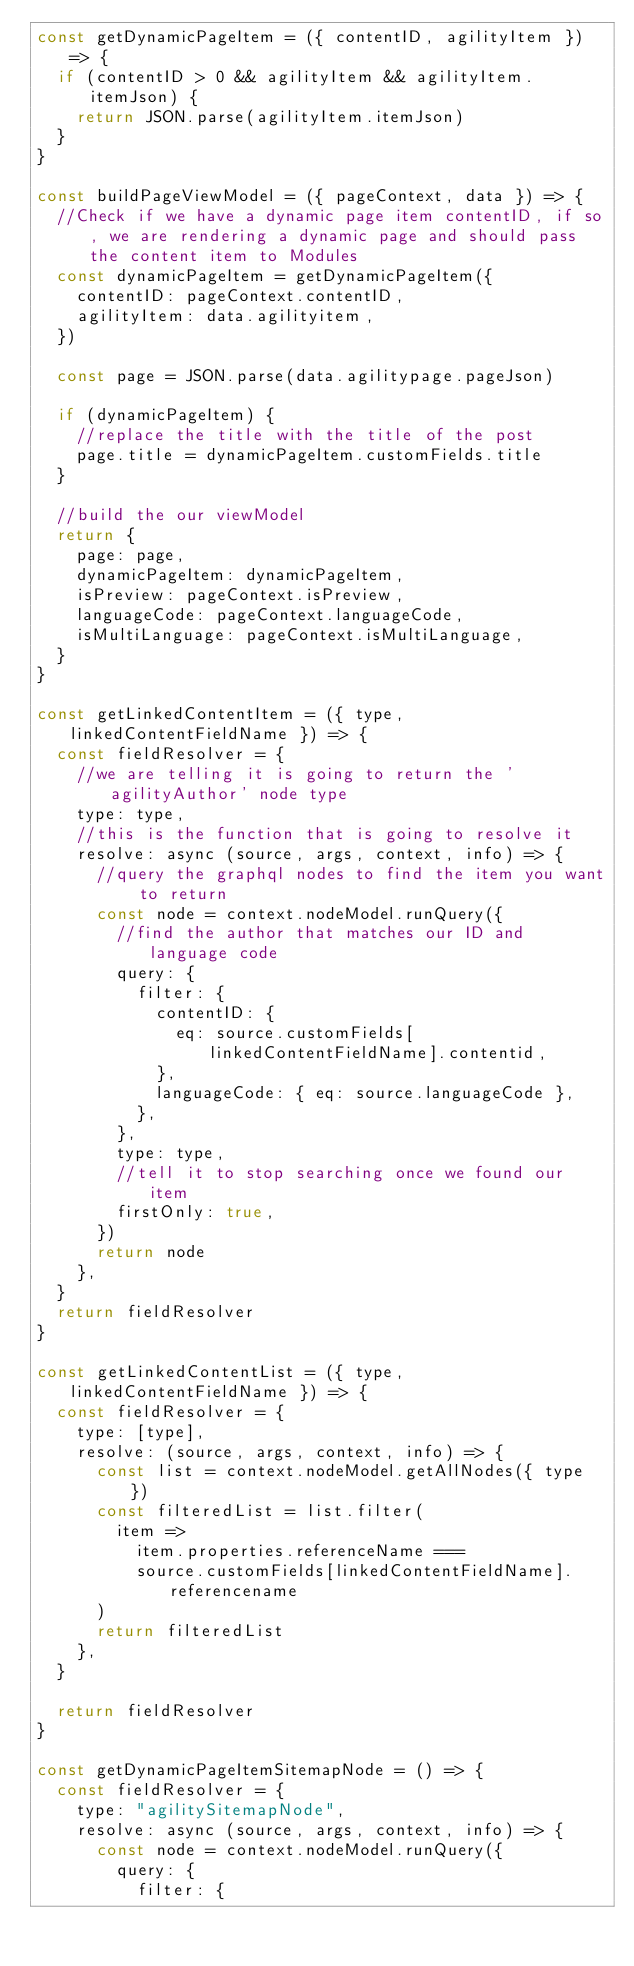Convert code to text. <code><loc_0><loc_0><loc_500><loc_500><_JavaScript_>const getDynamicPageItem = ({ contentID, agilityItem }) => {
  if (contentID > 0 && agilityItem && agilityItem.itemJson) {
    return JSON.parse(agilityItem.itemJson)
  }
}

const buildPageViewModel = ({ pageContext, data }) => {
  //Check if we have a dynamic page item contentID, if so, we are rendering a dynamic page and should pass the content item to Modules
  const dynamicPageItem = getDynamicPageItem({
    contentID: pageContext.contentID,
    agilityItem: data.agilityitem,
  })

  const page = JSON.parse(data.agilitypage.pageJson)

  if (dynamicPageItem) {
    //replace the title with the title of the post
    page.title = dynamicPageItem.customFields.title
  }

  //build the our viewModel
  return {
    page: page,
    dynamicPageItem: dynamicPageItem,
    isPreview: pageContext.isPreview,
    languageCode: pageContext.languageCode,
    isMultiLanguage: pageContext.isMultiLanguage,
  }
}

const getLinkedContentItem = ({ type, linkedContentFieldName }) => {
  const fieldResolver = {
    //we are telling it is going to return the 'agilityAuthor' node type
    type: type,
    //this is the function that is going to resolve it
    resolve: async (source, args, context, info) => {
      //query the graphql nodes to find the item you want to return
      const node = context.nodeModel.runQuery({
        //find the author that matches our ID and language code
        query: {
          filter: {
            contentID: {
              eq: source.customFields[linkedContentFieldName].contentid,
            },
            languageCode: { eq: source.languageCode },
          },
        },
        type: type,
        //tell it to stop searching once we found our item
        firstOnly: true,
      })
      return node
    },
  }
  return fieldResolver
}

const getLinkedContentList = ({ type, linkedContentFieldName }) => {
  const fieldResolver = {
    type: [type],
    resolve: (source, args, context, info) => {
      const list = context.nodeModel.getAllNodes({ type })
      const filteredList = list.filter(
        item =>
          item.properties.referenceName ===
          source.customFields[linkedContentFieldName].referencename
      )
      return filteredList
    },
  }

  return fieldResolver
}

const getDynamicPageItemSitemapNode = () => {
  const fieldResolver = {
    type: "agilitySitemapNode",
    resolve: async (source, args, context, info) => {
      const node = context.nodeModel.runQuery({
        query: {
          filter: {</code> 